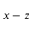<formula> <loc_0><loc_0><loc_500><loc_500>x - z</formula> 